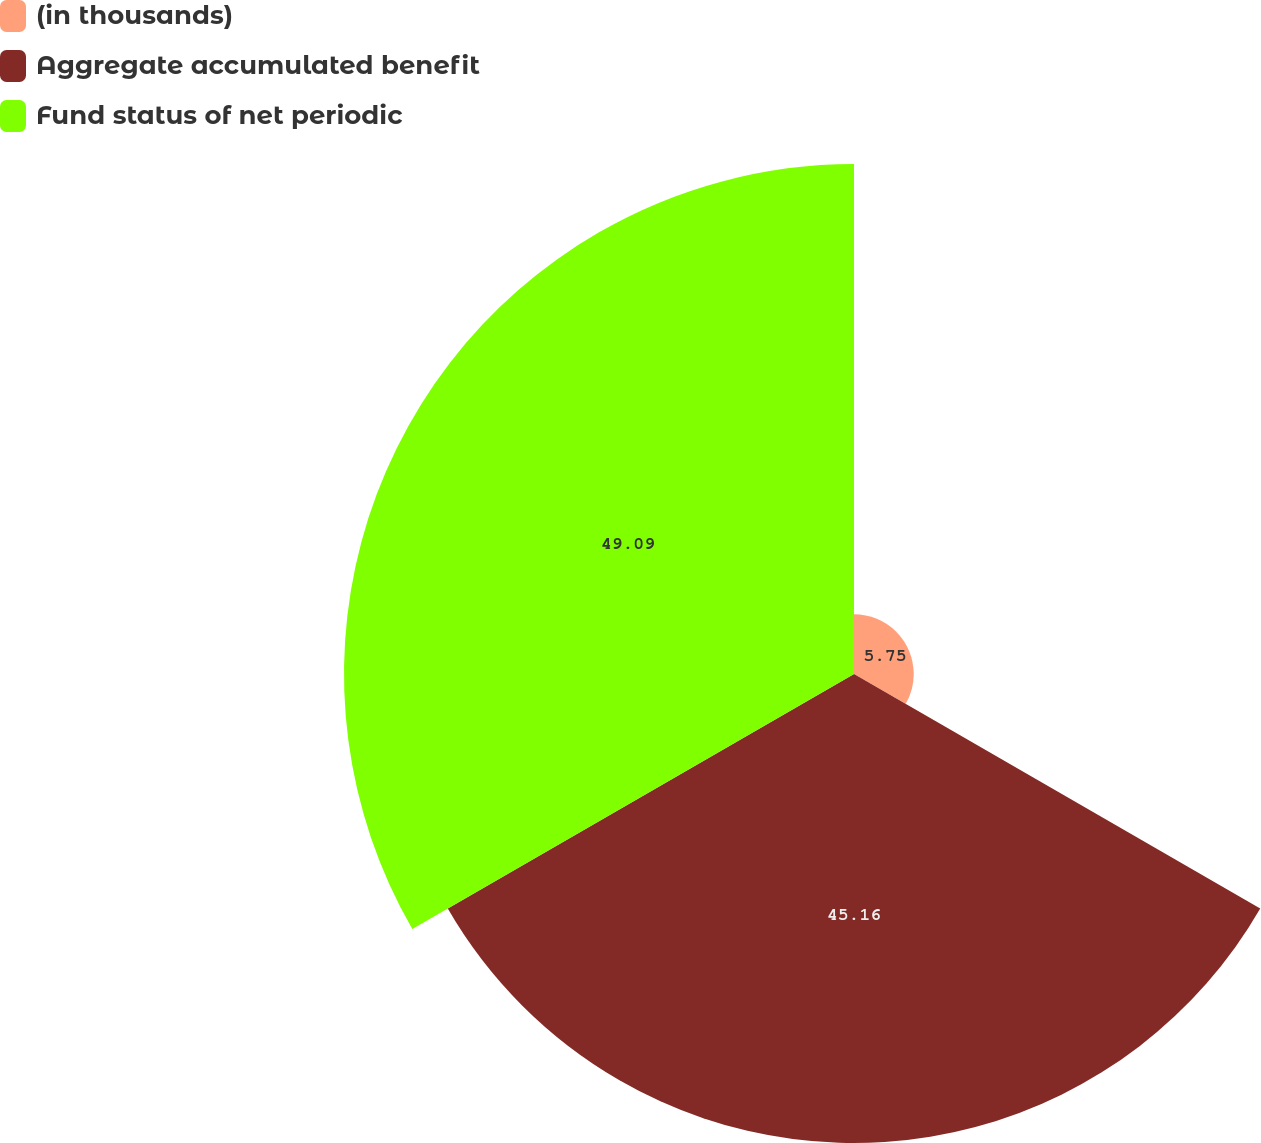<chart> <loc_0><loc_0><loc_500><loc_500><pie_chart><fcel>(in thousands)<fcel>Aggregate accumulated benefit<fcel>Fund status of net periodic<nl><fcel>5.75%<fcel>45.16%<fcel>49.1%<nl></chart> 